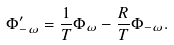<formula> <loc_0><loc_0><loc_500><loc_500>\Phi ^ { \prime } _ { - \omega } = \frac { 1 } { T } \Phi _ { \omega } - \frac { R } { T } \Phi _ { - \omega } .</formula> 